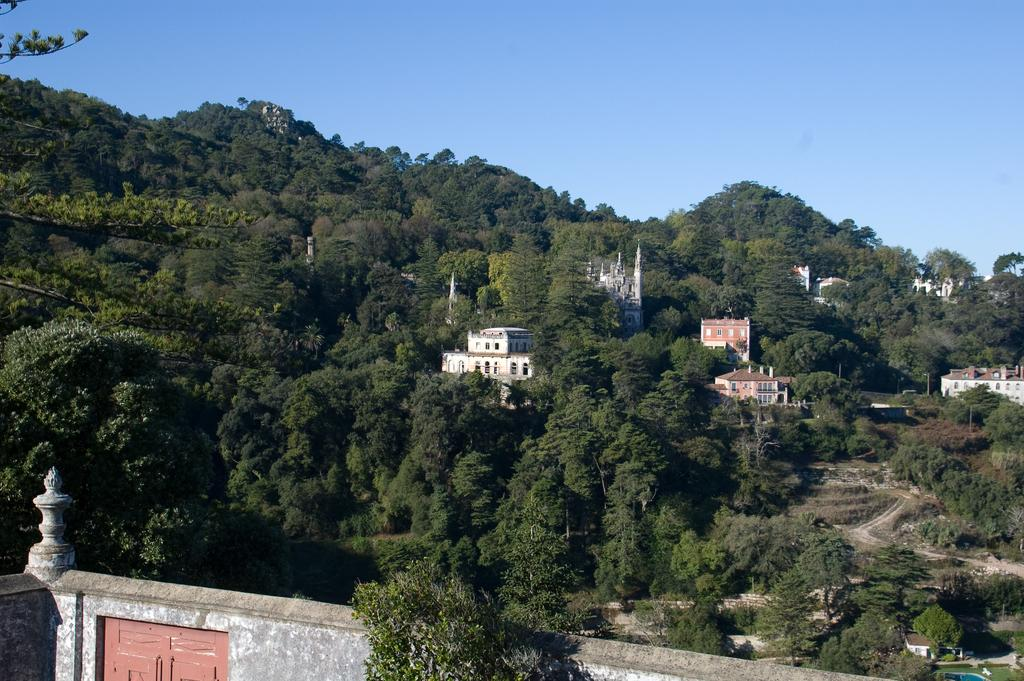What type of natural elements can be seen in the image? There are many trees in the image. What type of man-made structures are present in the image? There are buildings in the image. What architectural feature can be seen in the image? There is a wall with doors in the image. What is visible in the background of the image? The sky is visible in the background of the image. Can you describe the fight between the stranger and the wheel in the image? There is no fight between a stranger and a wheel present in the image. 